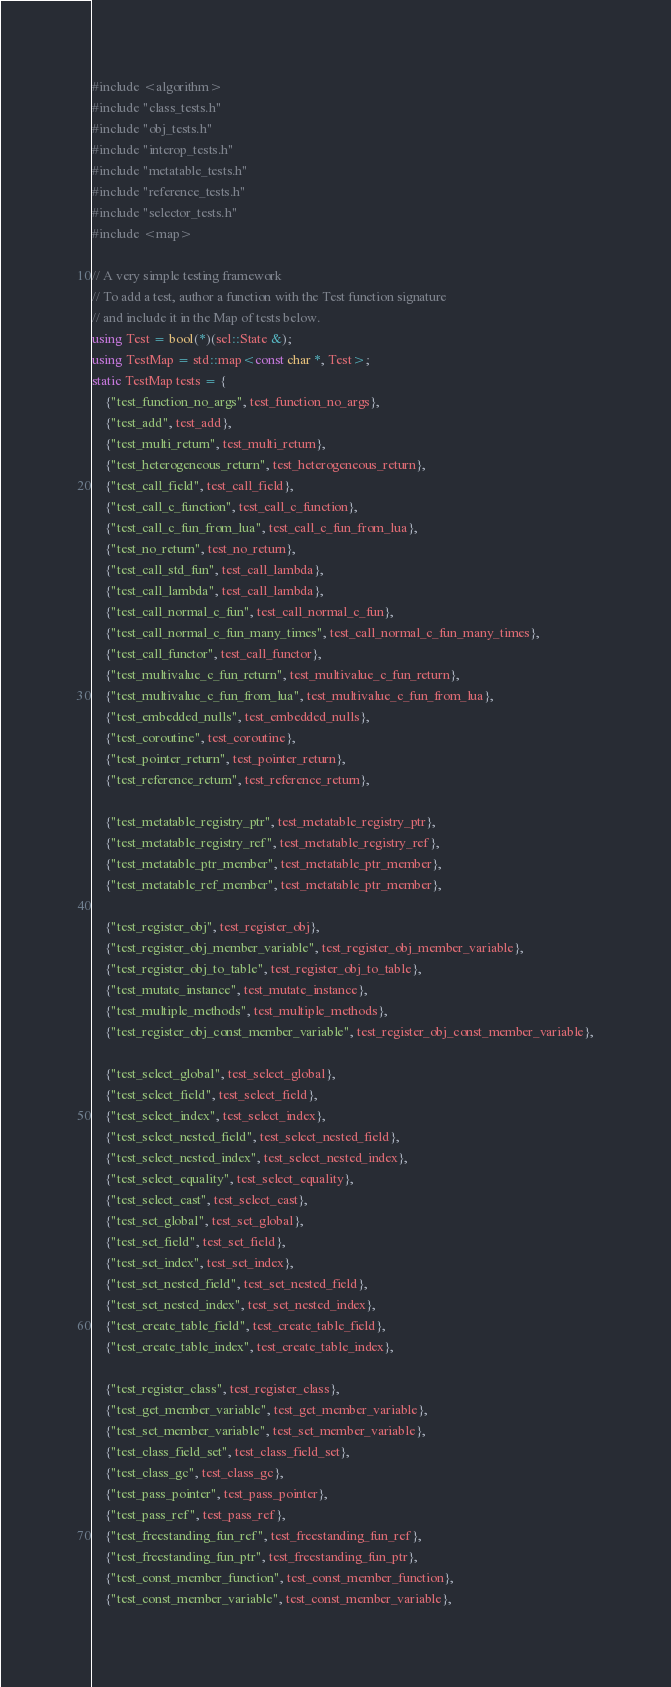<code> <loc_0><loc_0><loc_500><loc_500><_C++_>#include <algorithm>
#include "class_tests.h"
#include "obj_tests.h"
#include "interop_tests.h"
#include "metatable_tests.h"
#include "reference_tests.h"
#include "selector_tests.h"
#include <map>

// A very simple testing framework
// To add a test, author a function with the Test function signature
// and include it in the Map of tests below.
using Test = bool(*)(sel::State &);
using TestMap = std::map<const char *, Test>;
static TestMap tests = {
    {"test_function_no_args", test_function_no_args},
    {"test_add", test_add},
    {"test_multi_return", test_multi_return},
    {"test_heterogeneous_return", test_heterogeneous_return},
    {"test_call_field", test_call_field},
    {"test_call_c_function", test_call_c_function},
    {"test_call_c_fun_from_lua", test_call_c_fun_from_lua},
    {"test_no_return", test_no_return},
    {"test_call_std_fun", test_call_lambda},
    {"test_call_lambda", test_call_lambda},
    {"test_call_normal_c_fun", test_call_normal_c_fun},
    {"test_call_normal_c_fun_many_times", test_call_normal_c_fun_many_times},
    {"test_call_functor", test_call_functor},
    {"test_multivalue_c_fun_return", test_multivalue_c_fun_return},
    {"test_multivalue_c_fun_from_lua", test_multivalue_c_fun_from_lua},
    {"test_embedded_nulls", test_embedded_nulls},
    {"test_coroutine", test_coroutine},
    {"test_pointer_return", test_pointer_return},
    {"test_reference_return", test_reference_return},

    {"test_metatable_registry_ptr", test_metatable_registry_ptr},
    {"test_metatable_registry_ref", test_metatable_registry_ref},
    {"test_metatable_ptr_member", test_metatable_ptr_member},
    {"test_metatable_ref_member", test_metatable_ptr_member},

    {"test_register_obj", test_register_obj},
    {"test_register_obj_member_variable", test_register_obj_member_variable},
    {"test_register_obj_to_table", test_register_obj_to_table},
    {"test_mutate_instance", test_mutate_instance},
    {"test_multiple_methods", test_multiple_methods},
    {"test_register_obj_const_member_variable", test_register_obj_const_member_variable},

    {"test_select_global", test_select_global},
    {"test_select_field", test_select_field},
    {"test_select_index", test_select_index},
    {"test_select_nested_field", test_select_nested_field},
    {"test_select_nested_index", test_select_nested_index},
    {"test_select_equality", test_select_equality},
    {"test_select_cast", test_select_cast},
    {"test_set_global", test_set_global},
    {"test_set_field", test_set_field},
    {"test_set_index", test_set_index},
    {"test_set_nested_field", test_set_nested_field},
    {"test_set_nested_index", test_set_nested_index},
    {"test_create_table_field", test_create_table_field},
    {"test_create_table_index", test_create_table_index},

    {"test_register_class", test_register_class},
    {"test_get_member_variable", test_get_member_variable},
    {"test_set_member_variable", test_set_member_variable},
    {"test_class_field_set", test_class_field_set},
    {"test_class_gc", test_class_gc},
    {"test_pass_pointer", test_pass_pointer},
    {"test_pass_ref", test_pass_ref},
    {"test_freestanding_fun_ref", test_freestanding_fun_ref},
    {"test_freestanding_fun_ptr", test_freestanding_fun_ptr},
    {"test_const_member_function", test_const_member_function},
    {"test_const_member_variable", test_const_member_variable},
</code> 